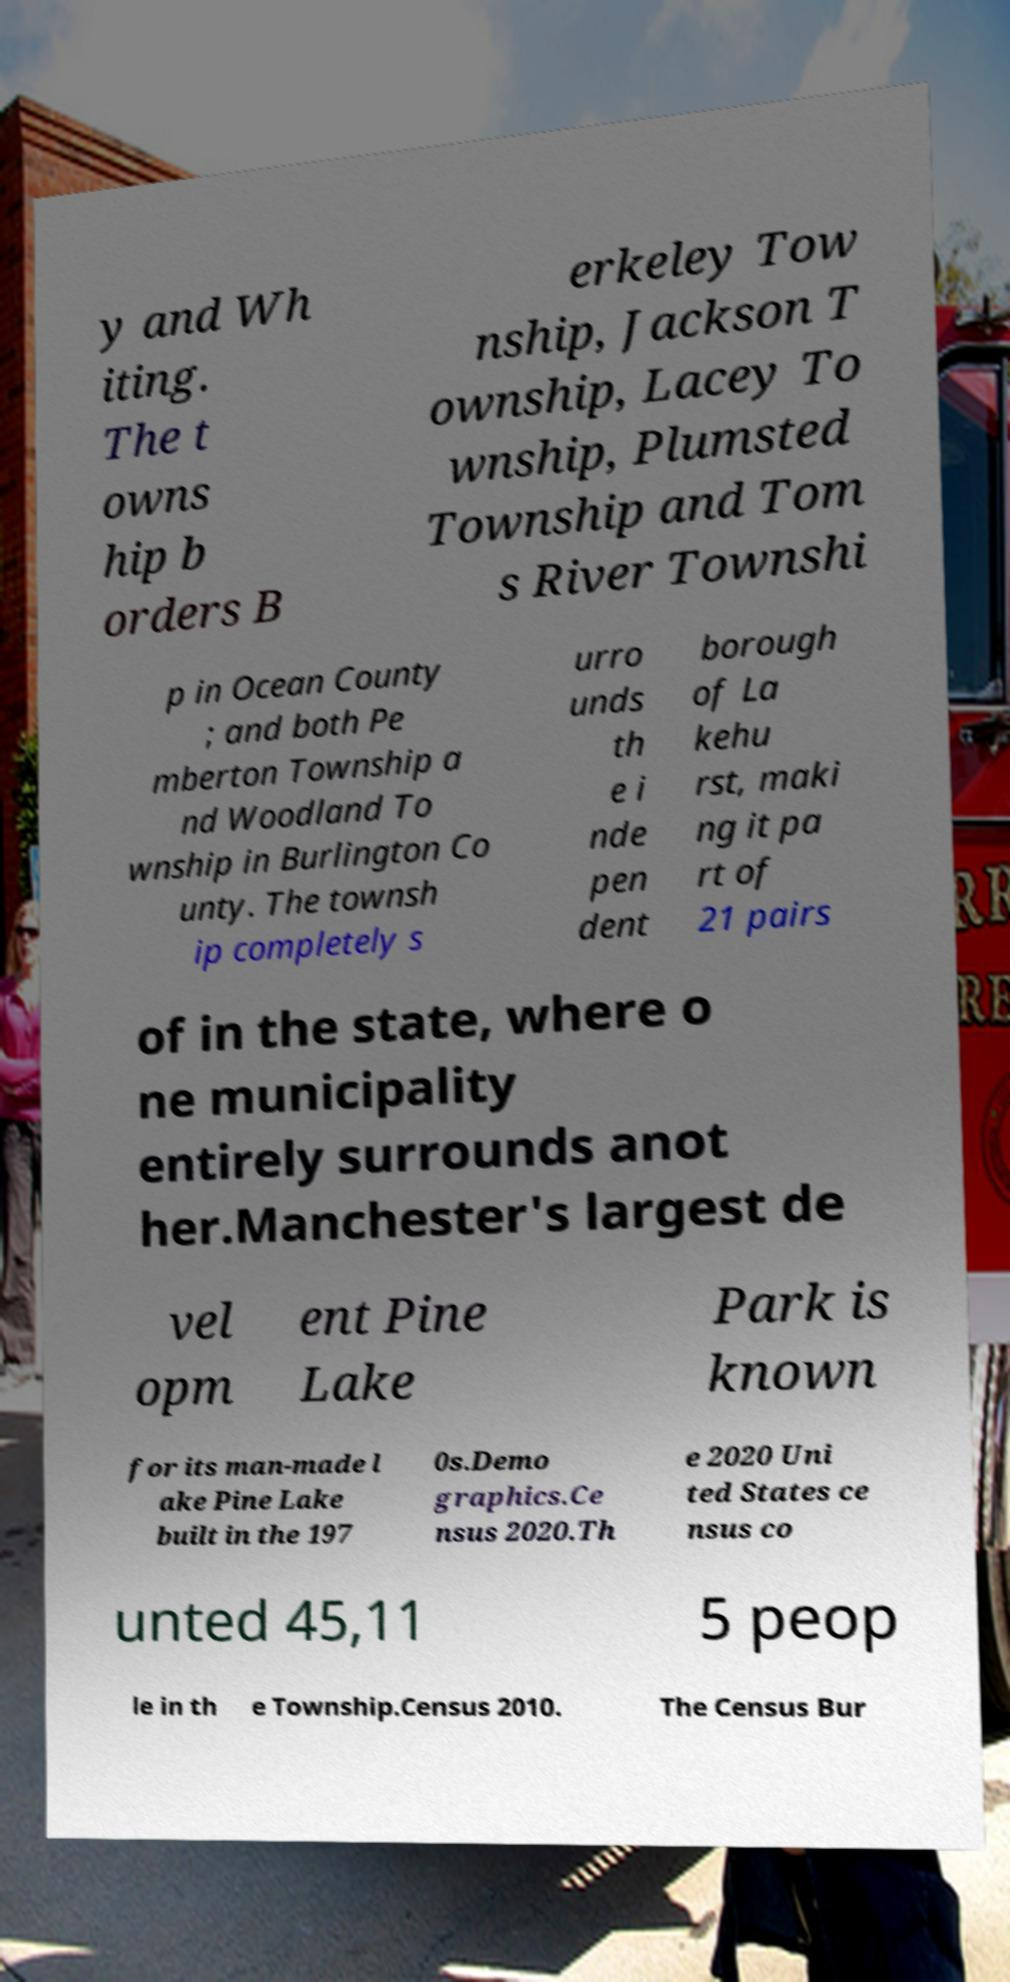Please read and relay the text visible in this image. What does it say? y and Wh iting. The t owns hip b orders B erkeley Tow nship, Jackson T ownship, Lacey To wnship, Plumsted Township and Tom s River Townshi p in Ocean County ; and both Pe mberton Township a nd Woodland To wnship in Burlington Co unty. The townsh ip completely s urro unds th e i nde pen dent borough of La kehu rst, maki ng it pa rt of 21 pairs of in the state, where o ne municipality entirely surrounds anot her.Manchester's largest de vel opm ent Pine Lake Park is known for its man-made l ake Pine Lake built in the 197 0s.Demo graphics.Ce nsus 2020.Th e 2020 Uni ted States ce nsus co unted 45,11 5 peop le in th e Township.Census 2010. The Census Bur 